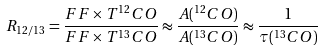<formula> <loc_0><loc_0><loc_500><loc_500>R _ { 1 2 / 1 3 } = \frac { F F \times T ^ { 1 2 } C O } { F F \times T ^ { 1 3 } C O } \approx \frac { A ( ^ { 1 2 } C O ) } { A ( ^ { 1 3 } C O ) } \approx \frac { 1 } { \tau ( ^ { 1 3 } C O ) }</formula> 